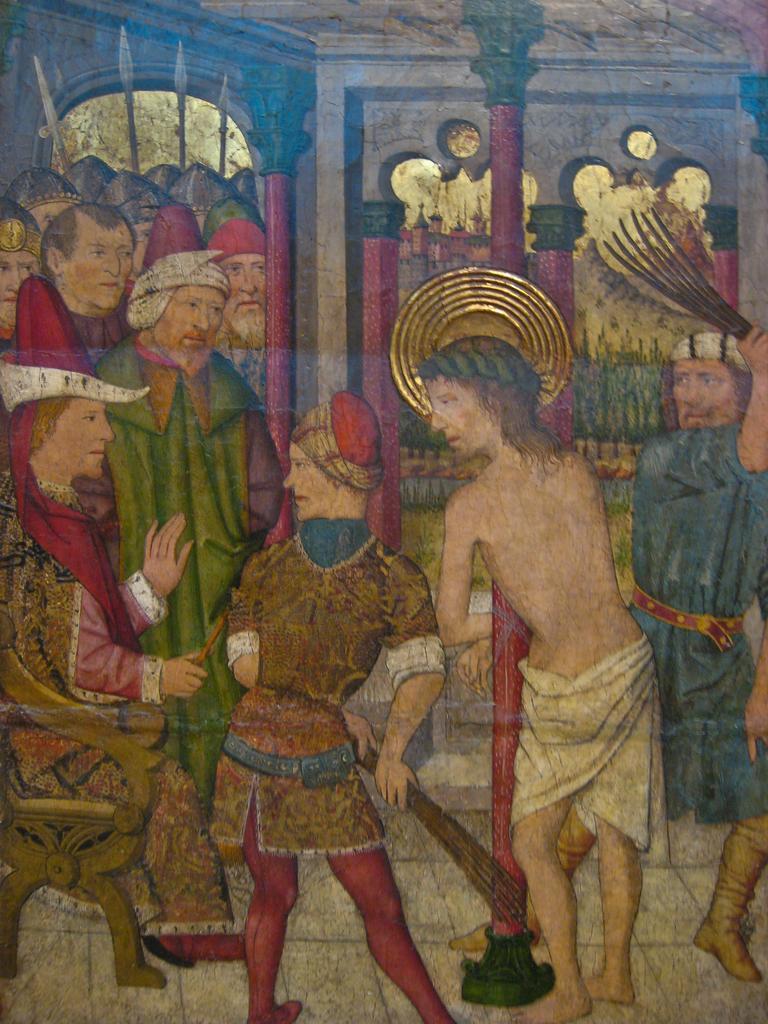Describe this image in one or two sentences. In this picture, we can see an art of a few people, pillars and an arch. 